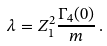<formula> <loc_0><loc_0><loc_500><loc_500>\lambda = Z _ { 1 } ^ { 2 } \frac { \Gamma _ { 4 } ( 0 ) } { m } \, .</formula> 